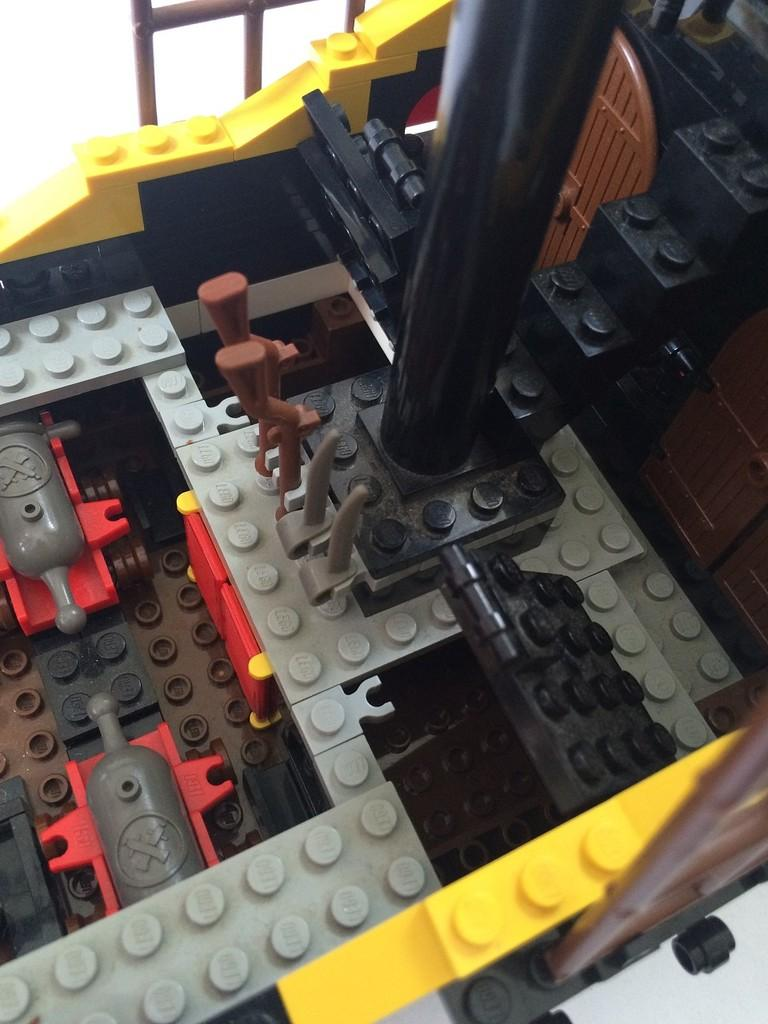What is the main object in the image? There is a toy in the image. What material is the toy made of? The toy is made with building blocks. How many letters are being carried by the beggar in the image? There is no beggar or letters present in the image. 